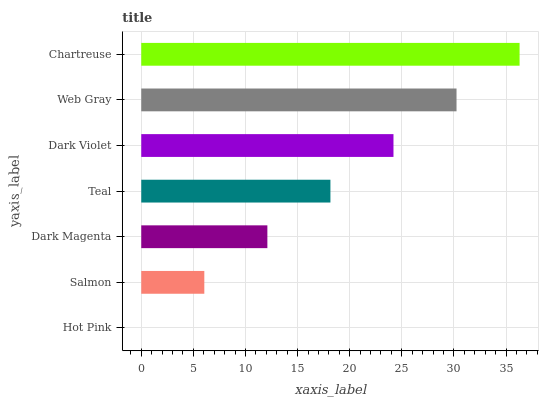Is Hot Pink the minimum?
Answer yes or no. Yes. Is Chartreuse the maximum?
Answer yes or no. Yes. Is Salmon the minimum?
Answer yes or no. No. Is Salmon the maximum?
Answer yes or no. No. Is Salmon greater than Hot Pink?
Answer yes or no. Yes. Is Hot Pink less than Salmon?
Answer yes or no. Yes. Is Hot Pink greater than Salmon?
Answer yes or no. No. Is Salmon less than Hot Pink?
Answer yes or no. No. Is Teal the high median?
Answer yes or no. Yes. Is Teal the low median?
Answer yes or no. Yes. Is Dark Violet the high median?
Answer yes or no. No. Is Hot Pink the low median?
Answer yes or no. No. 